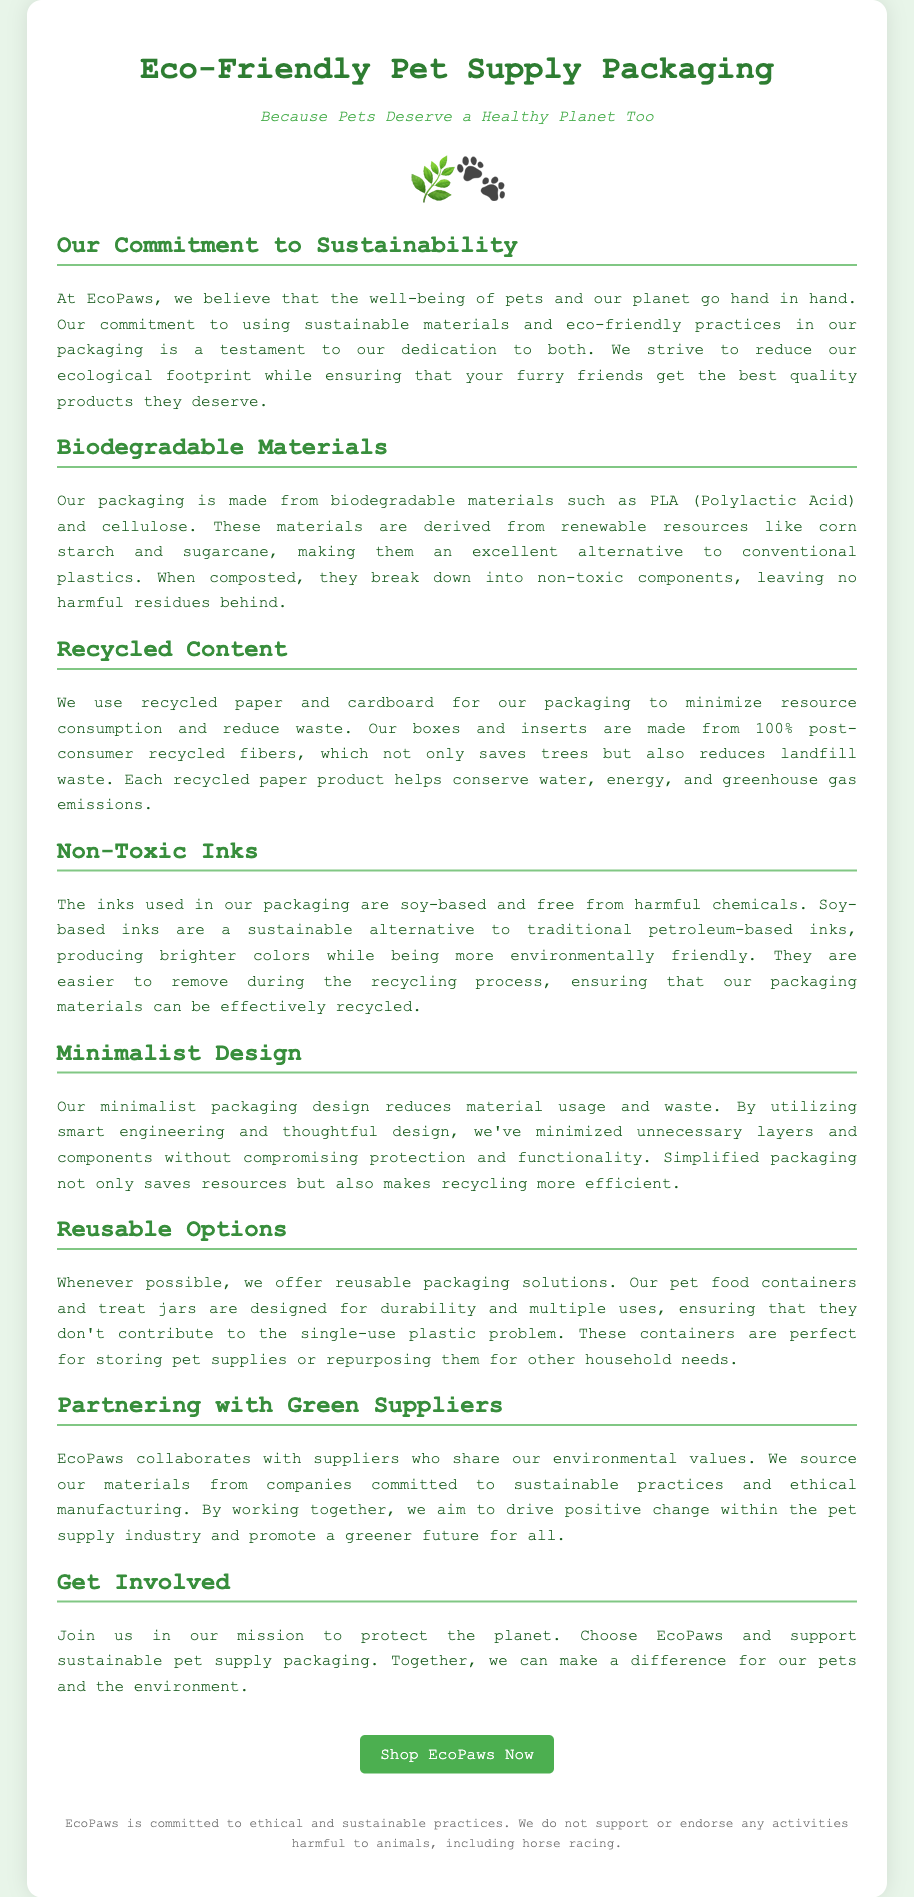What is the name of the company? The company name mentioned in the document is highlighted at the top, which is EcoPaws.
Answer: EcoPaws What materials are used for biodegradable packaging? The document specifies the biodegradable materials used in the packaging, which includes PLA and cellulose.
Answer: PLA and cellulose What percent of the packaging is made from recycled content? The document states that the paper and cardboard used for packaging are made from 100% post-consumer recycled fibers.
Answer: 100% What type of inks are used in the packaging? The document discusses the inks used in the packaging, specifying that they are soy-based and free from harmful chemicals.
Answer: Soy-based What is the main benefit of minimalist design? The minimalist design reduces material usage and waste, as mentioned in the document.
Answer: Reduces material usage and waste What does EcoPaws offer for reusable options? The document describes that EcoPaws offers durable pet food containers and treat jars designed for multiple uses.
Answer: Pet food containers and treat jars What is the primary goal of EcoPaws concerning sustainability? The document states the commitment to sustainability as reducing ecological footprint and ensuring quality products.
Answer: Reducing ecological footprint What is one way EcoPaws is partnering with suppliers? The document mentions that EcoPaws collaborates with suppliers who share environmental values.
Answer: Collaborates with green suppliers What type of packaging solutions does EcoPaws offer? The document explains the types of packaging solutions offered by EcoPaws, pointing out that they include reusable options.
Answer: Reusable options 